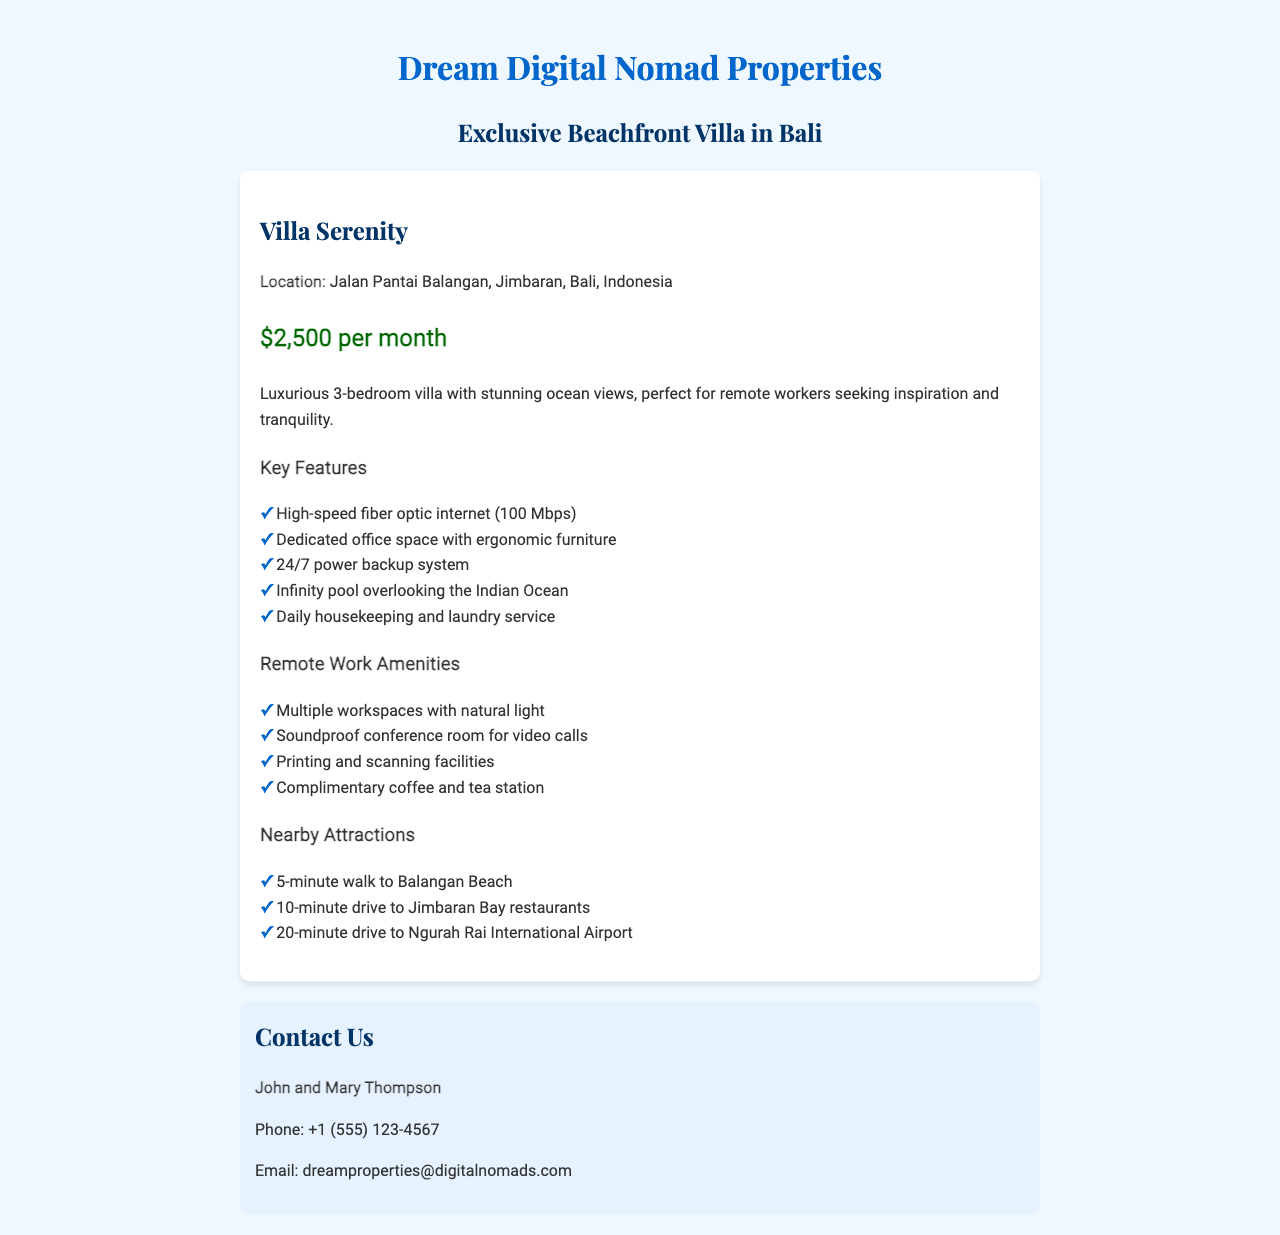What is the name of the villa? The name of the villa is prominently displayed in the header section of the document.
Answer: Villa Serenity What is the monthly rental price? The document explicitly states the rental price near the top of the property information section.
Answer: $2,500 per month How many bedrooms does the villa have? The number of bedrooms is mentioned in the description of the villa's luxurious features.
Answer: 3 What internet speed is available in the villa? The document lists internet speed as a key feature under the property description section.
Answer: 100 Mbps How far is the villa from Balangan Beach? The distance to Balangan Beach is provided in the nearby attractions section.
Answer: 5-minute walk What kind of furniture is available in the dedicated office space? Details about the office space include specifics about the type of furniture included.
Answer: Ergonomic furniture How many nearby attractions are listed in the document? The document includes a list of nearby attractions, which can be counted.
Answer: 3 Who are the contact persons for the property? The contact information section states the names of the individuals to reach out to.
Answer: John and Mary Thompson What services are provided on a daily basis? Daily services are detailed in the key features section of the document.
Answer: Housekeeping and laundry service 